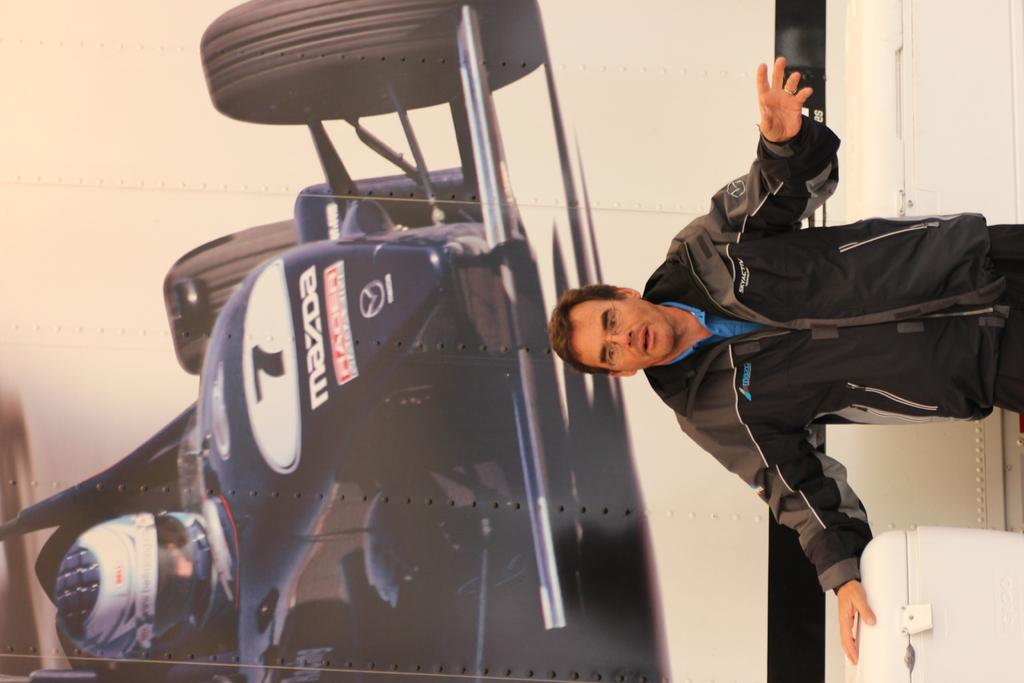<image>
Render a clear and concise summary of the photo. A man standing in front of a picture of a Mazda race car. 